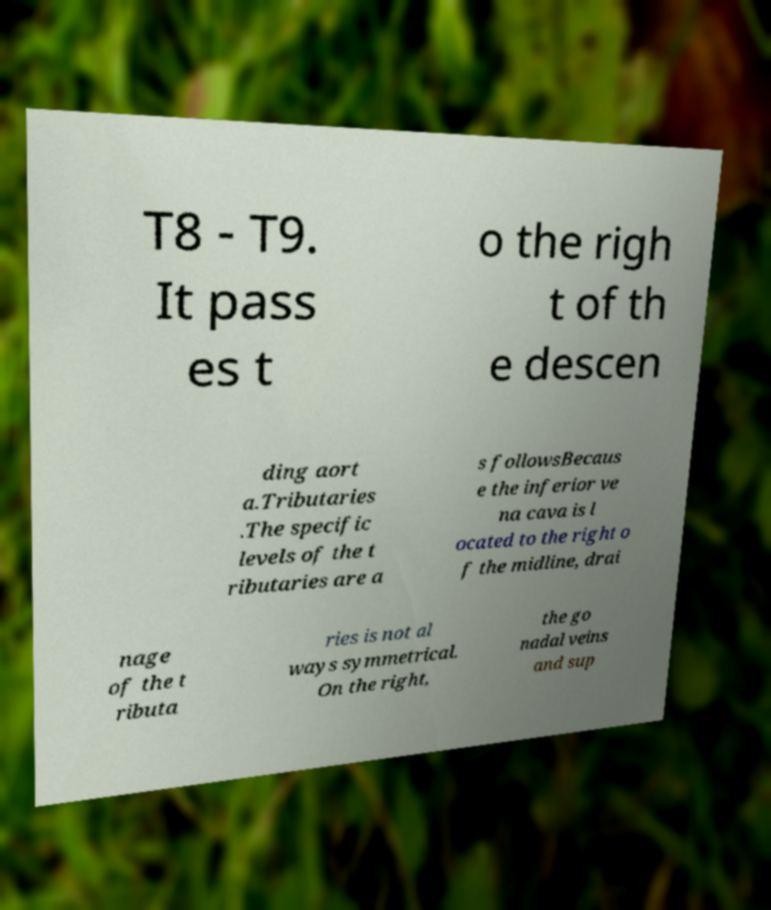For documentation purposes, I need the text within this image transcribed. Could you provide that? T8 - T9. It pass es t o the righ t of th e descen ding aort a.Tributaries .The specific levels of the t ributaries are a s followsBecaus e the inferior ve na cava is l ocated to the right o f the midline, drai nage of the t ributa ries is not al ways symmetrical. On the right, the go nadal veins and sup 